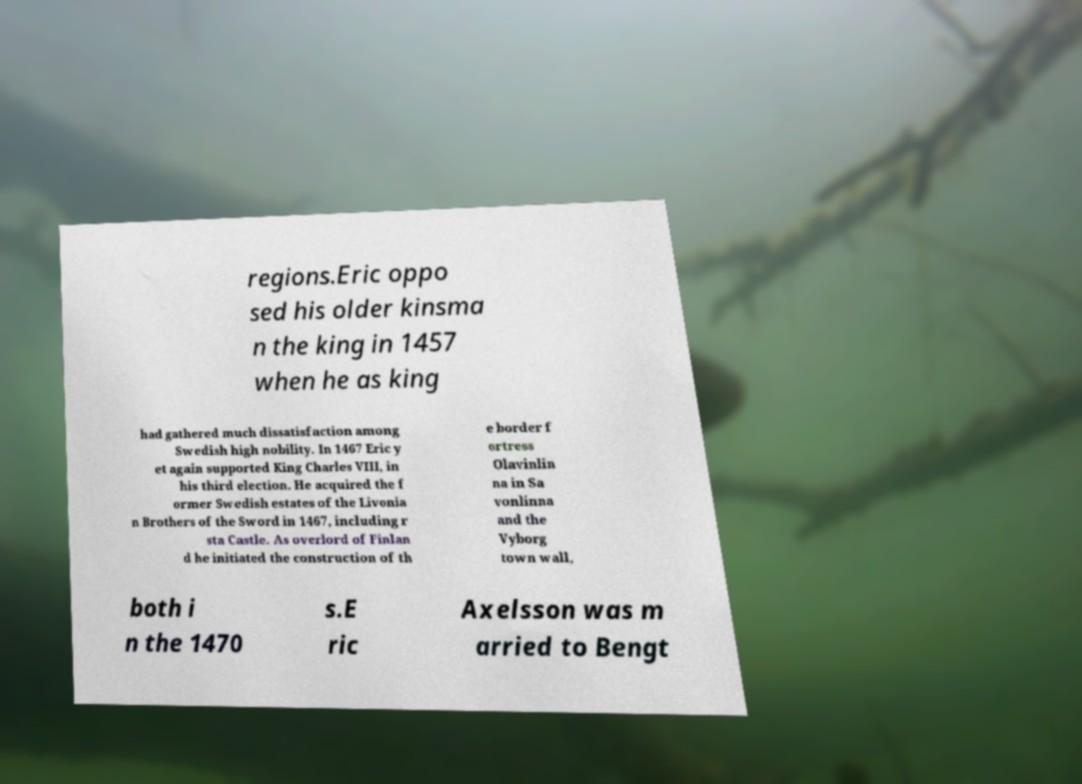Can you accurately transcribe the text from the provided image for me? regions.Eric oppo sed his older kinsma n the king in 1457 when he as king had gathered much dissatisfaction among Swedish high nobility. In 1467 Eric y et again supported King Charles VIII, in his third election. He acquired the f ormer Swedish estates of the Livonia n Brothers of the Sword in 1467, including r sta Castle. As overlord of Finlan d he initiated the construction of th e border f ortress Olavinlin na in Sa vonlinna and the Vyborg town wall, both i n the 1470 s.E ric Axelsson was m arried to Bengt 